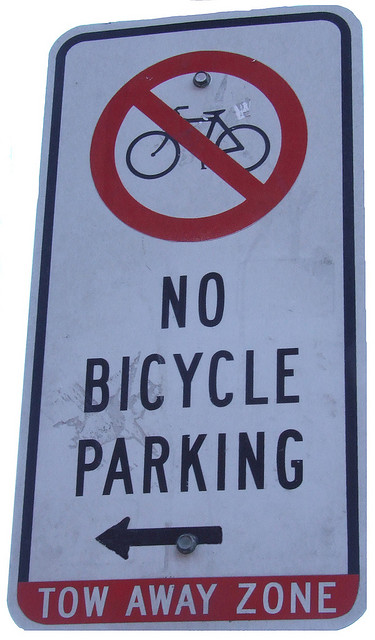Identify the text displayed in this image. NO PARKING BICYCLE ZONE AWAY TOW 